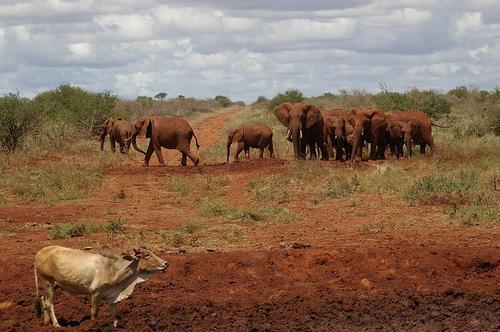How many elephants are there?
Give a very brief answer. 2. How many people are wearing hats?
Give a very brief answer. 0. 